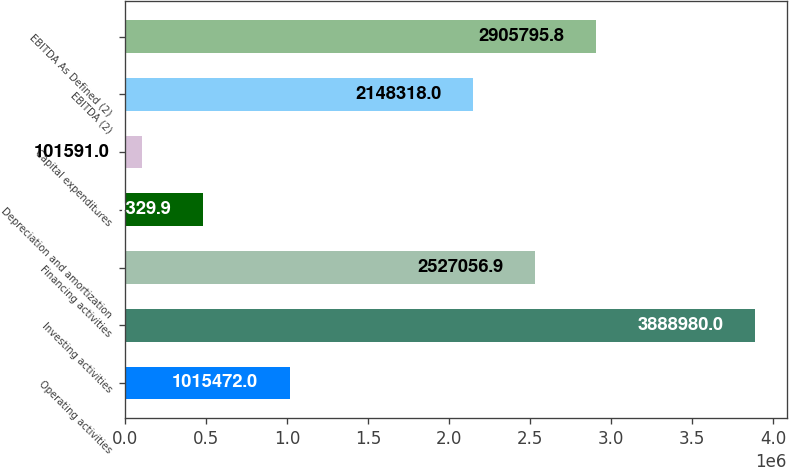Convert chart. <chart><loc_0><loc_0><loc_500><loc_500><bar_chart><fcel>Operating activities<fcel>Investing activities<fcel>Financing activities<fcel>Depreciation and amortization<fcel>Capital expenditures<fcel>EBITDA (2)<fcel>EBITDA As Defined (2)<nl><fcel>1.01547e+06<fcel>3.88898e+06<fcel>2.52706e+06<fcel>480330<fcel>101591<fcel>2.14832e+06<fcel>2.9058e+06<nl></chart> 